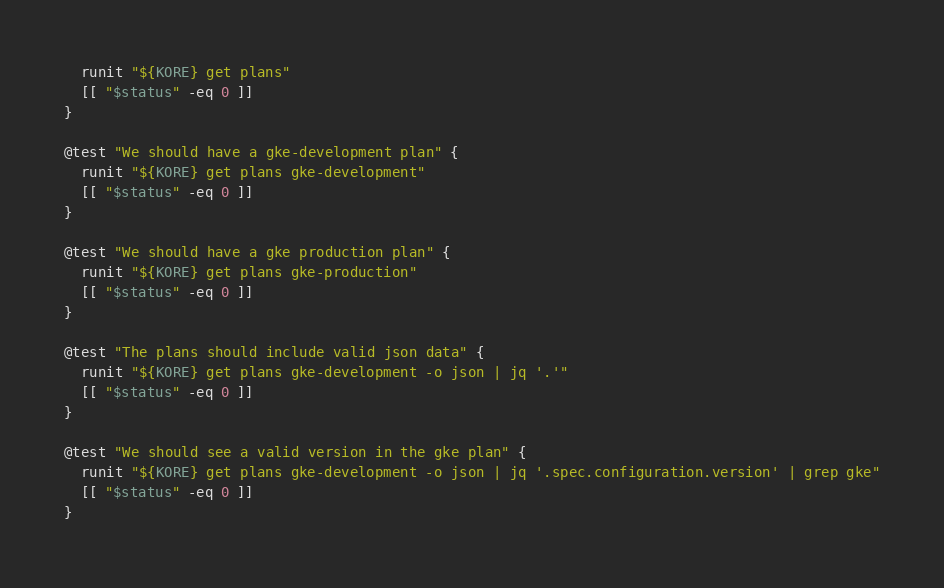Convert code to text. <code><loc_0><loc_0><loc_500><loc_500><_Bash_>  runit "${KORE} get plans"
  [[ "$status" -eq 0 ]]
}

@test "We should have a gke-development plan" {
  runit "${KORE} get plans gke-development"
  [[ "$status" -eq 0 ]]
}

@test "We should have a gke production plan" {
  runit "${KORE} get plans gke-production"
  [[ "$status" -eq 0 ]]
}

@test "The plans should include valid json data" {
  runit "${KORE} get plans gke-development -o json | jq '.'"
  [[ "$status" -eq 0 ]]
}

@test "We should see a valid version in the gke plan" {
  runit "${KORE} get plans gke-development -o json | jq '.spec.configuration.version' | grep gke"
  [[ "$status" -eq 0 ]]
}</code> 